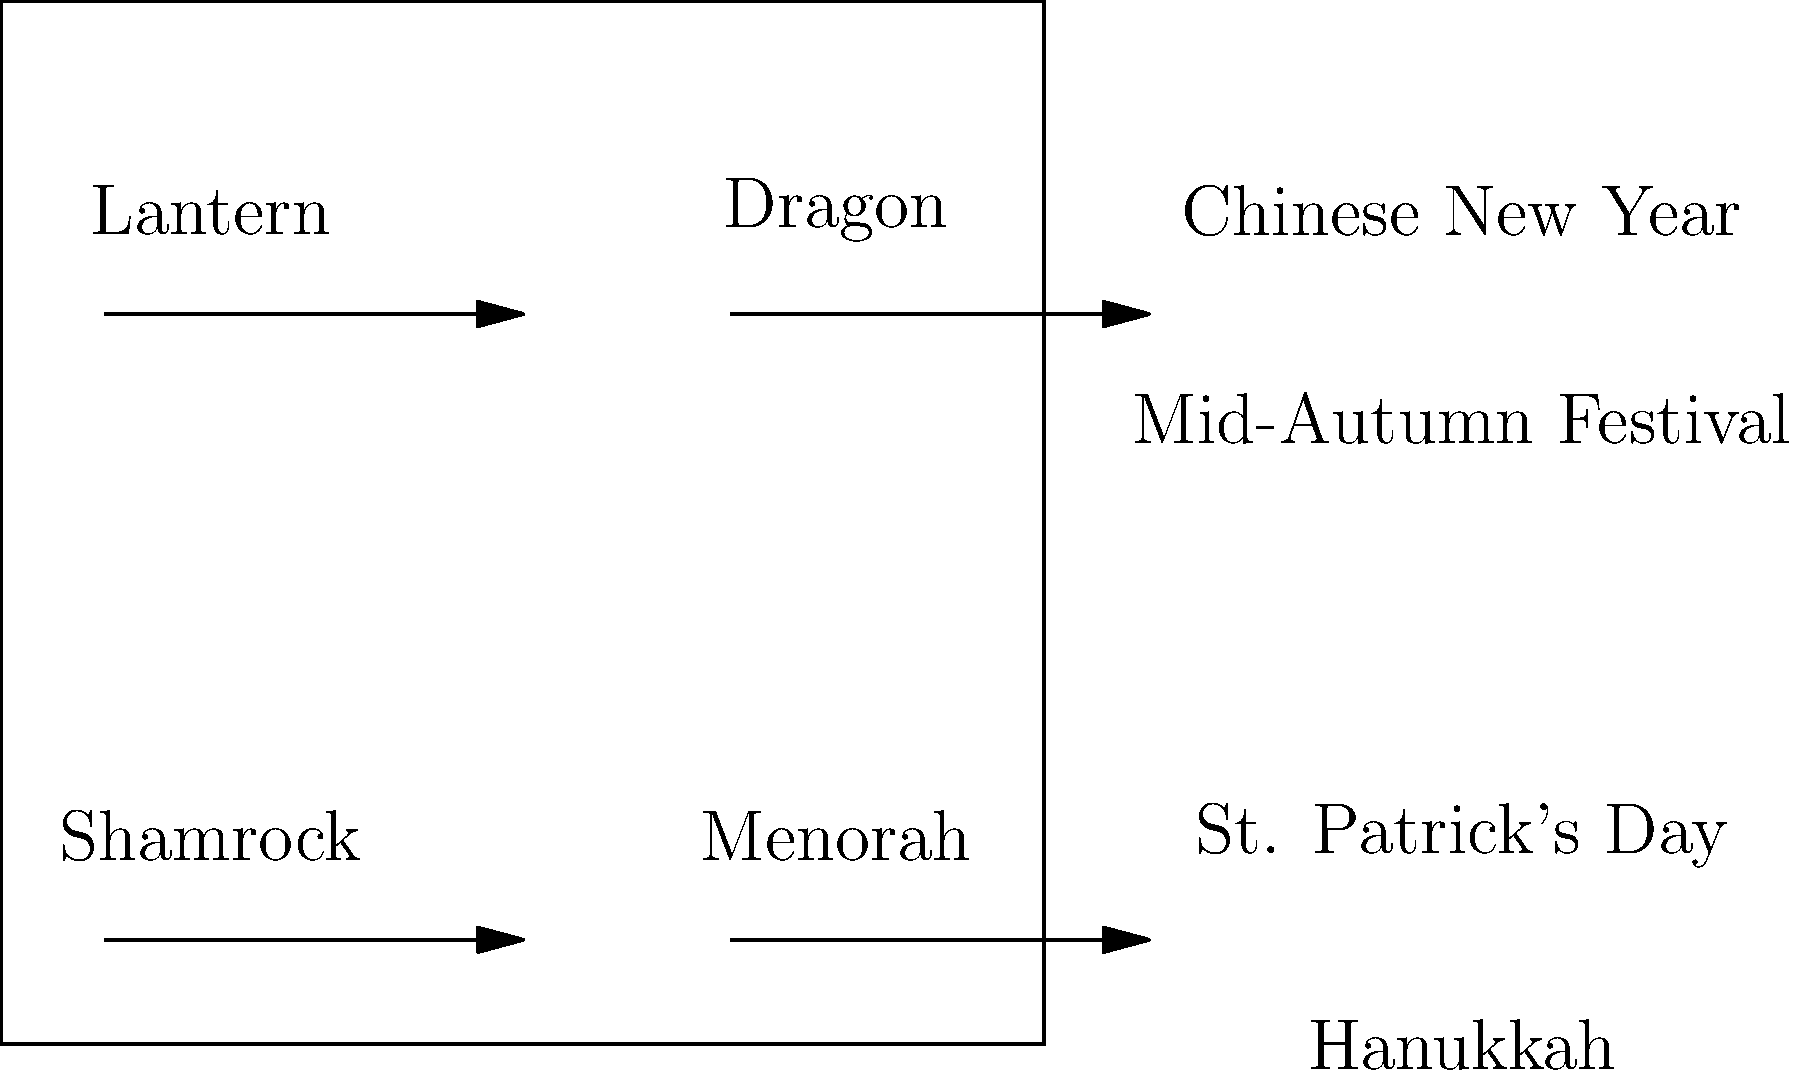Match the festival symbols to their corresponding cultural celebrations by drawing lines between them. Which symbol is associated with the Mid-Autumn Festival? To answer this question, let's analyze each symbol and its cultural significance:

1. Lantern: This is a common symbol in Chinese culture, used in various festivals. However, it is most prominently associated with the Mid-Autumn Festival, where lanterns are lit and displayed as part of the celebration.

2. Dragon: While dragons are important in Chinese culture year-round, they are particularly significant during Chinese New Year celebrations, where dragon dances are performed.

3. Shamrock: This three-leaved plant is a symbol of Ireland and is strongly associated with St. Patrick's Day celebrations.

4. Menorah: This candelabrum with nine branches is a key symbol of Hanukkah, the Jewish Festival of Lights.

Given these associations, we can match:
- Lantern to Mid-Autumn Festival
- Dragon to Chinese New Year
- Shamrock to St. Patrick's Day
- Menorah to Hanukkah

Therefore, the symbol associated with the Mid-Autumn Festival is the lantern.
Answer: Lantern 